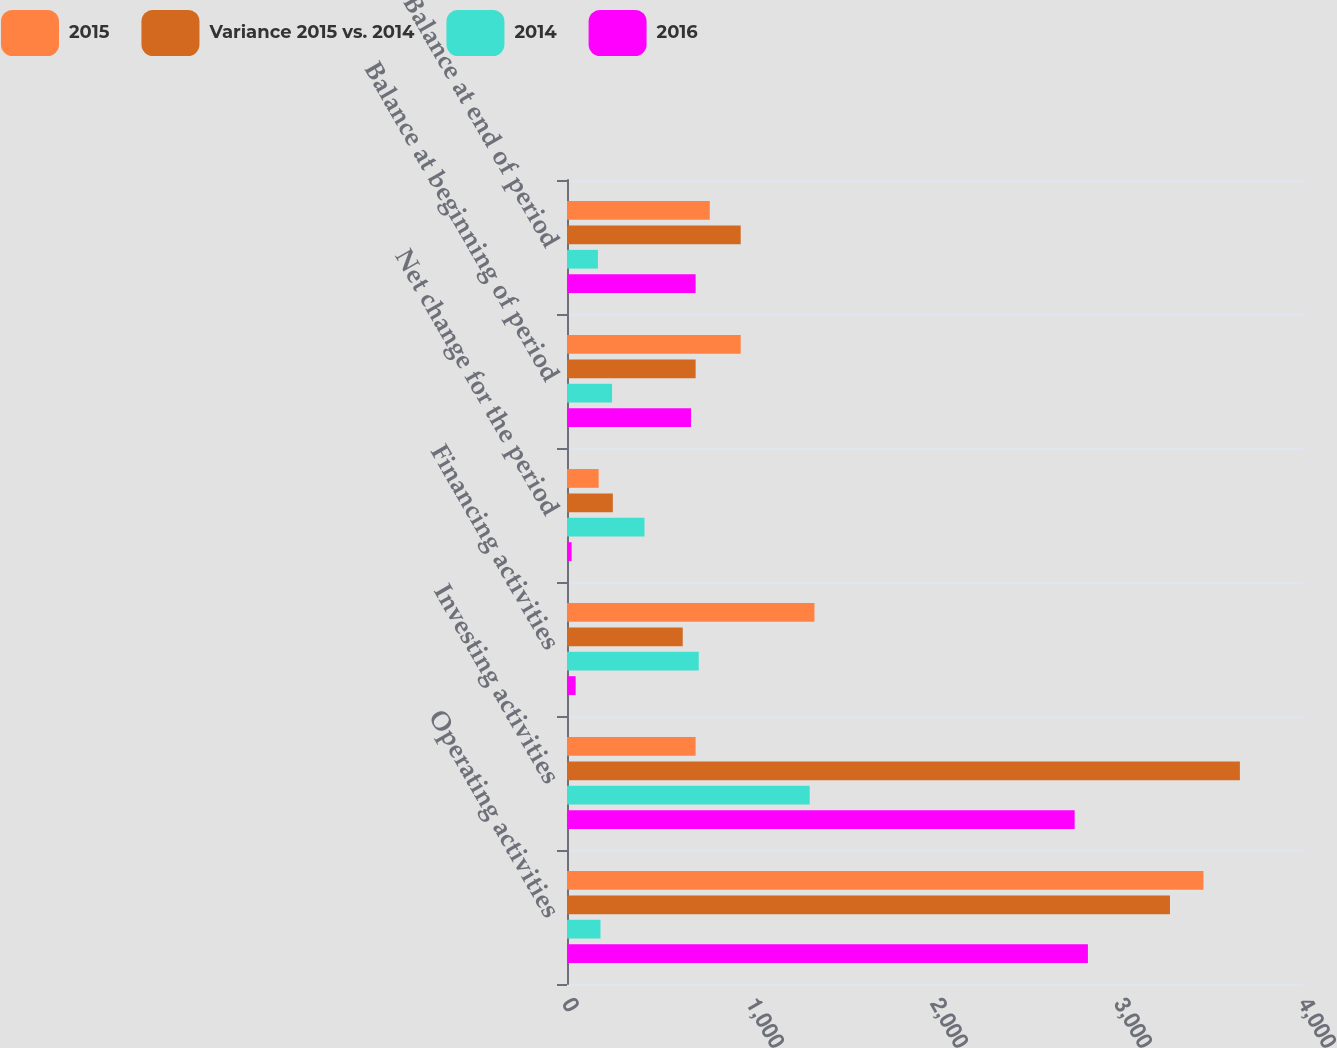<chart> <loc_0><loc_0><loc_500><loc_500><stacked_bar_chart><ecel><fcel>Operating activities<fcel>Investing activities<fcel>Financing activities<fcel>Net change for the period<fcel>Balance at beginning of period<fcel>Balance at end of period<nl><fcel>2015<fcel>3459<fcel>699<fcel>1345<fcel>172<fcel>944<fcel>776<nl><fcel>Variance 2015 vs. 2014<fcel>3277<fcel>3657<fcel>629<fcel>249<fcel>699<fcel>944<nl><fcel>2014<fcel>182<fcel>1319<fcel>716<fcel>421<fcel>245<fcel>168<nl><fcel>2016<fcel>2831<fcel>2759<fcel>47<fcel>25<fcel>674<fcel>699<nl></chart> 